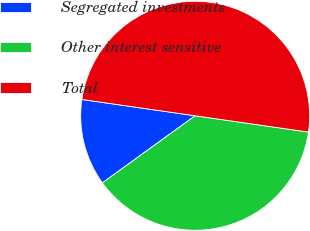<chart> <loc_0><loc_0><loc_500><loc_500><pie_chart><fcel>Segregated investments<fcel>Other interest sensitive<fcel>Total<nl><fcel>12.24%<fcel>37.76%<fcel>50.0%<nl></chart> 